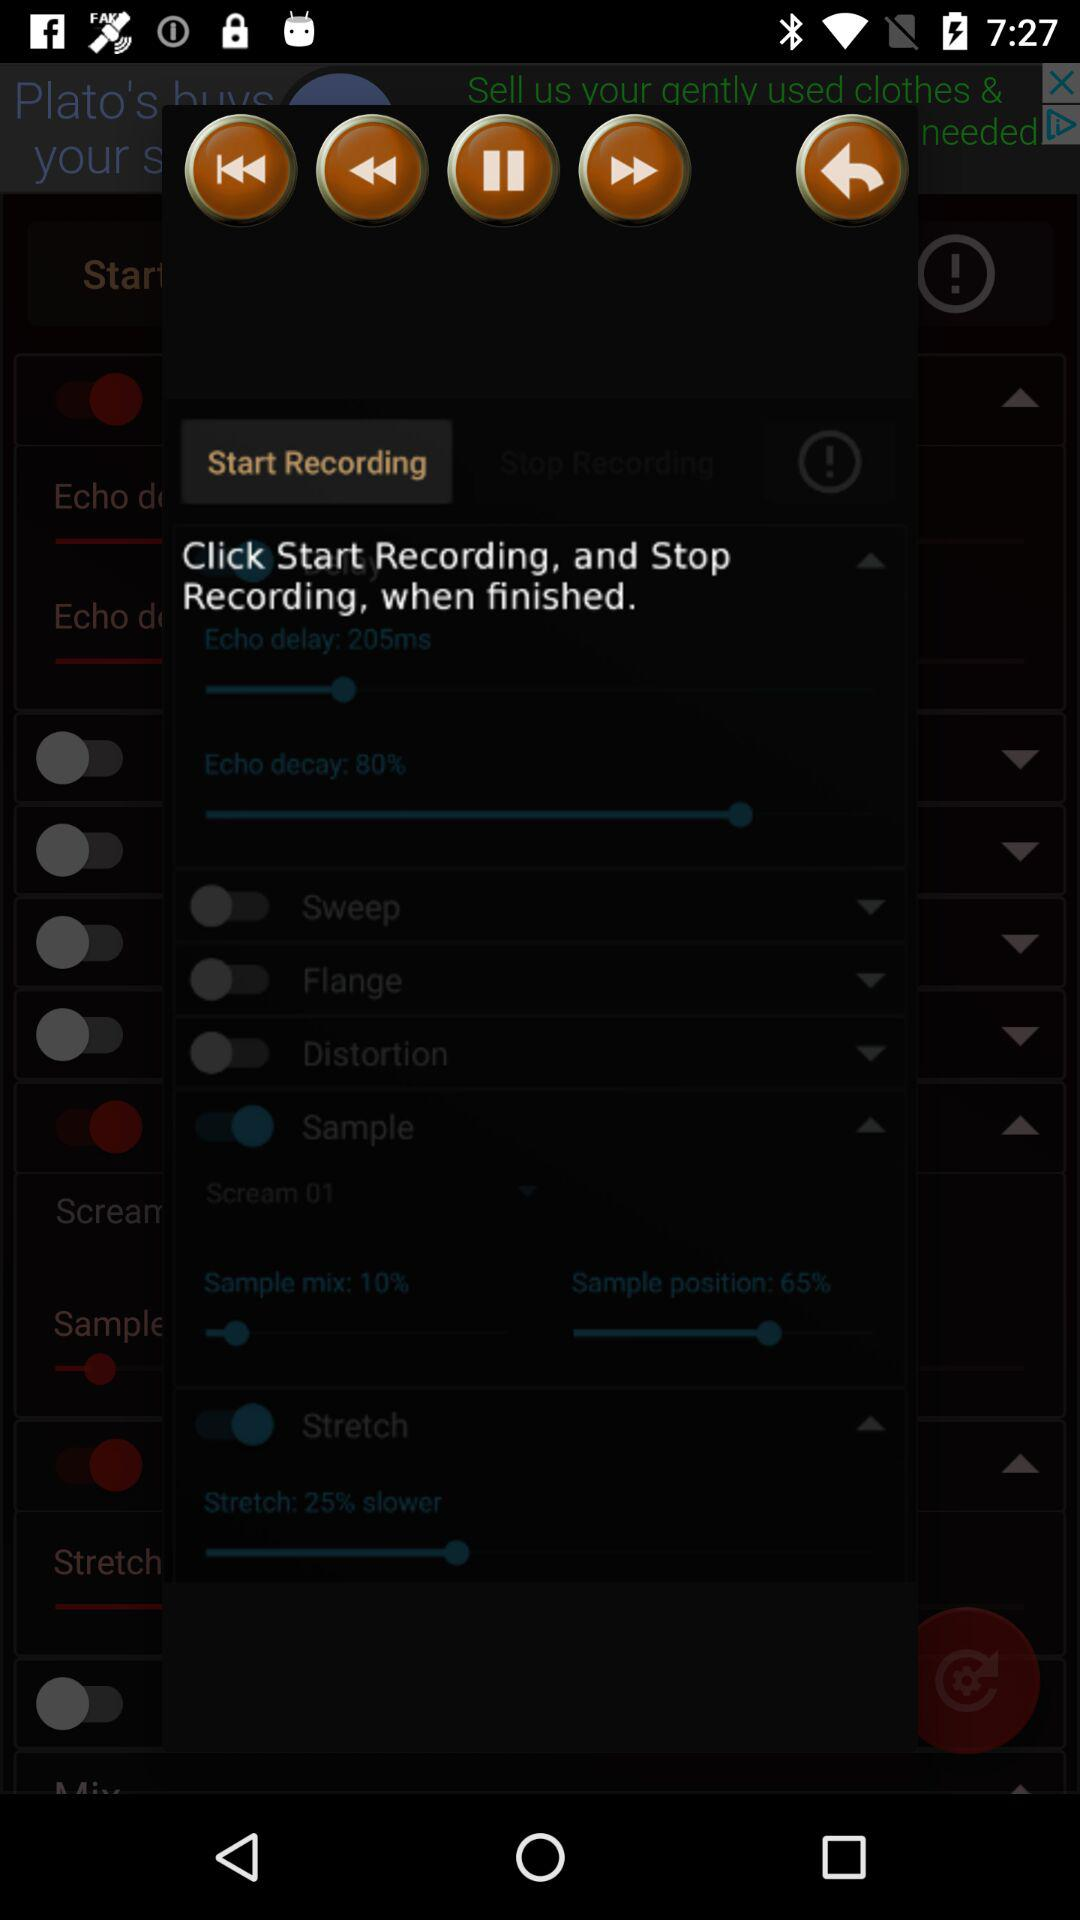How much percentage of sample is mixed?
When the provided information is insufficient, respond with <no answer>. <no answer> 